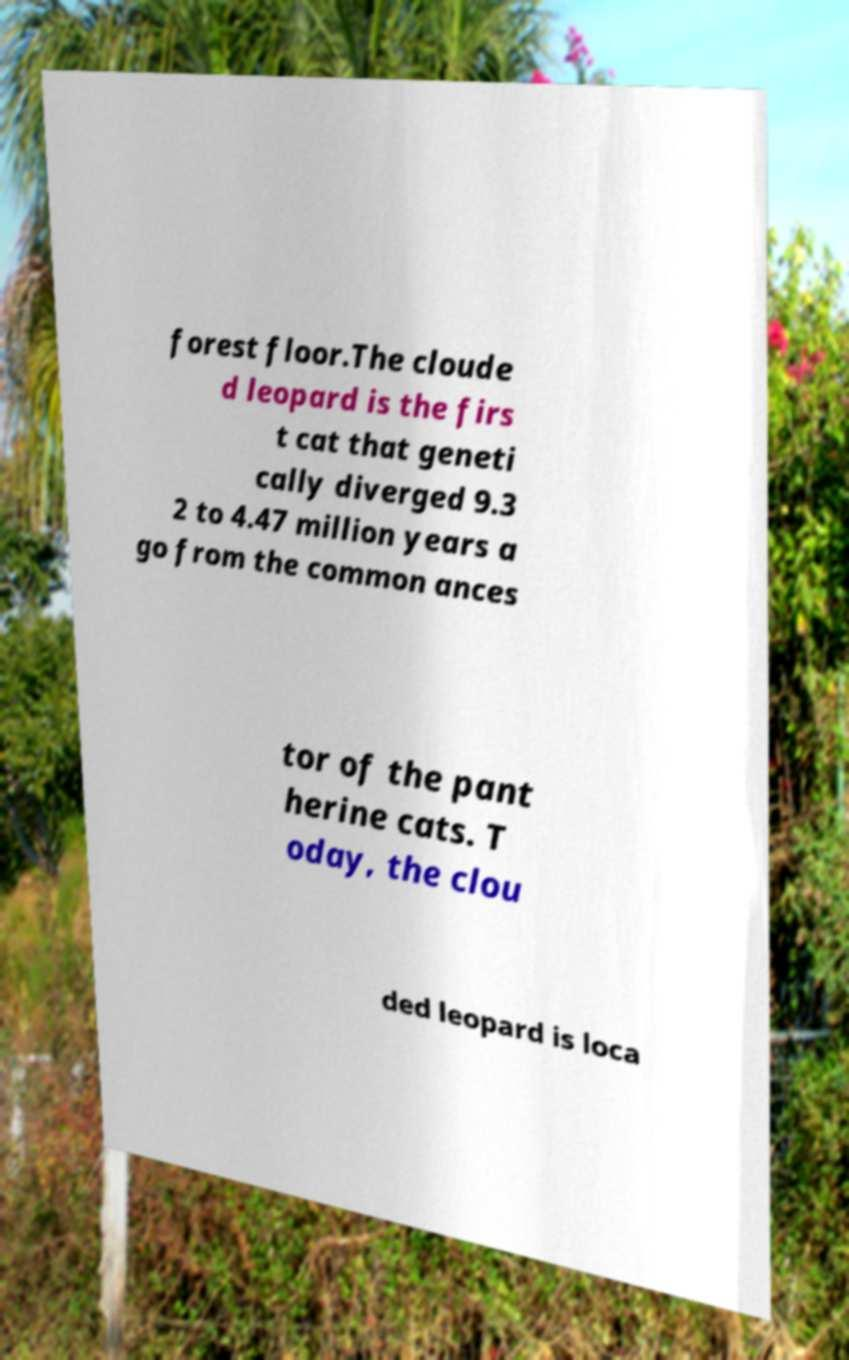Could you assist in decoding the text presented in this image and type it out clearly? forest floor.The cloude d leopard is the firs t cat that geneti cally diverged 9.3 2 to 4.47 million years a go from the common ances tor of the pant herine cats. T oday, the clou ded leopard is loca 